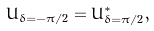<formula> <loc_0><loc_0><loc_500><loc_500>U _ { \delta = - \pi / 2 } = U ^ { * } _ { \delta = \pi / 2 } ,</formula> 